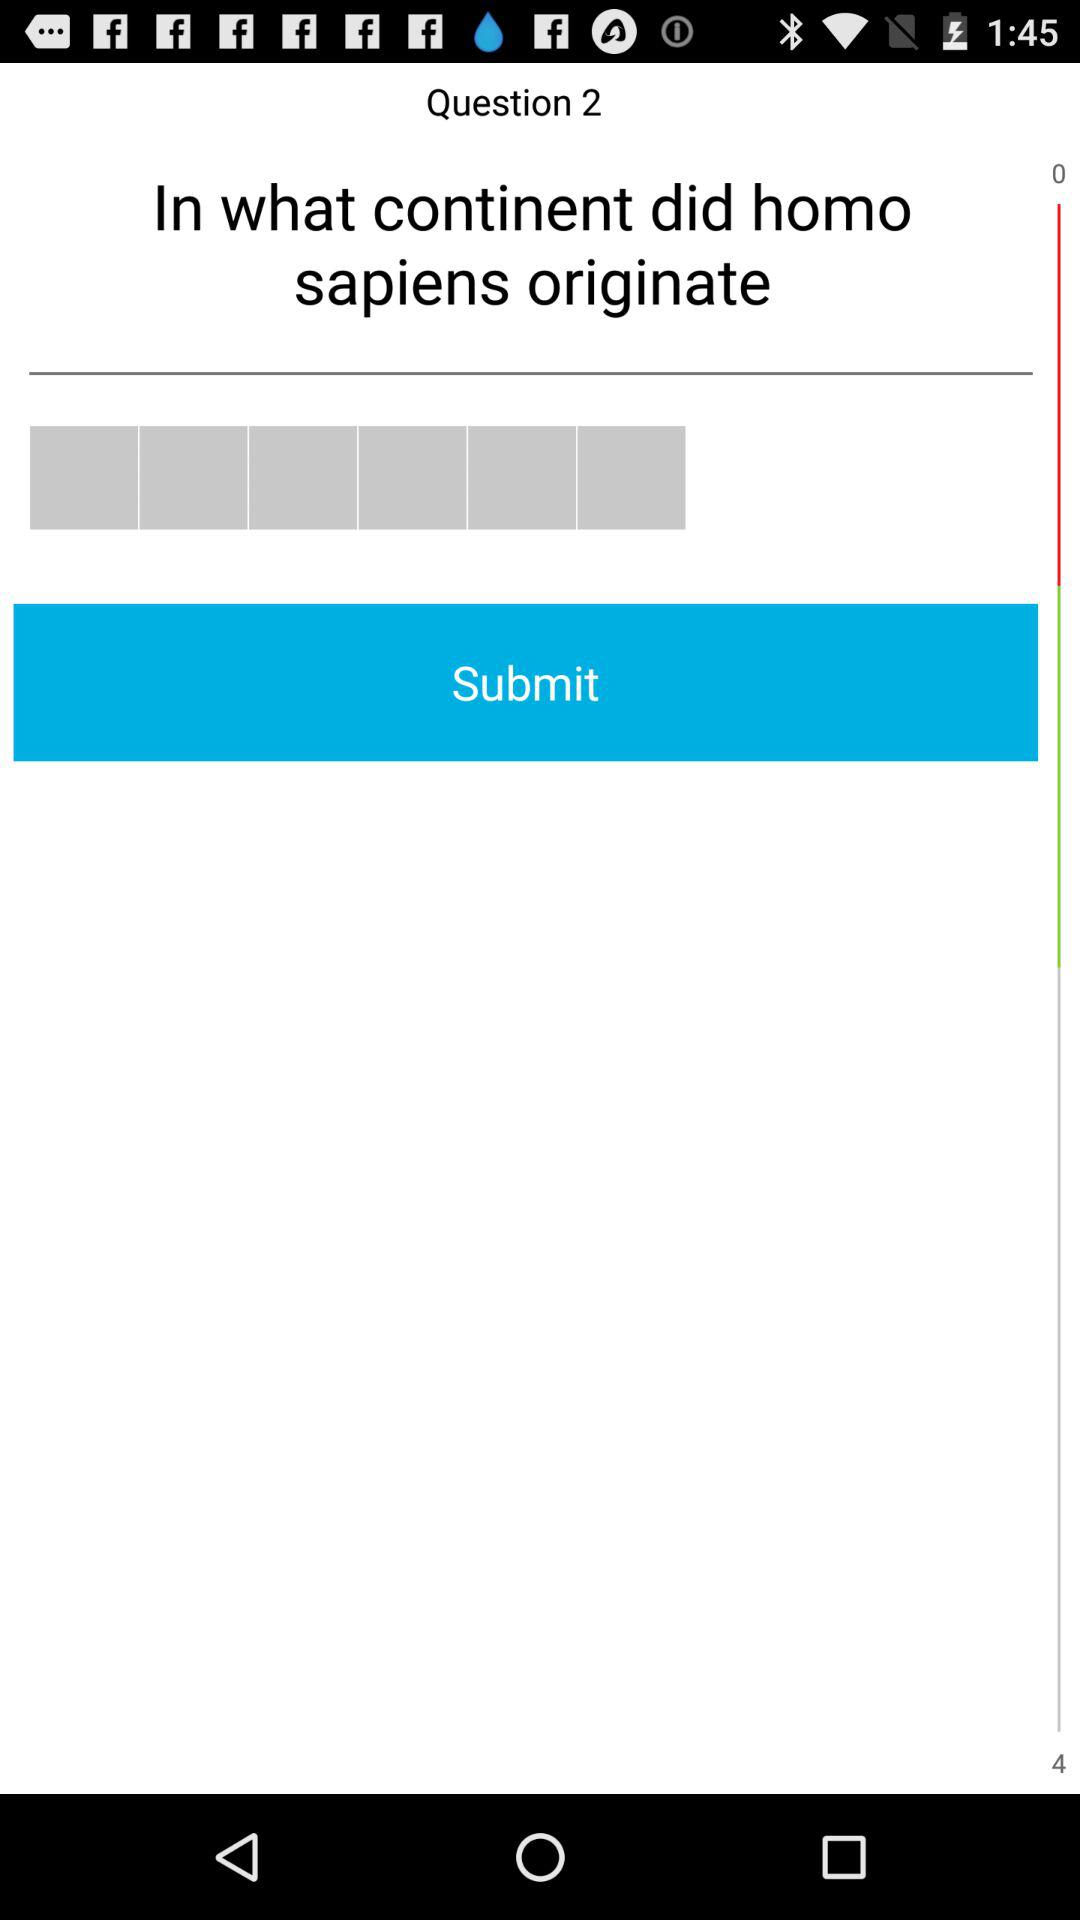How many questions in total are there?
When the provided information is insufficient, respond with <no answer>. <no answer> 